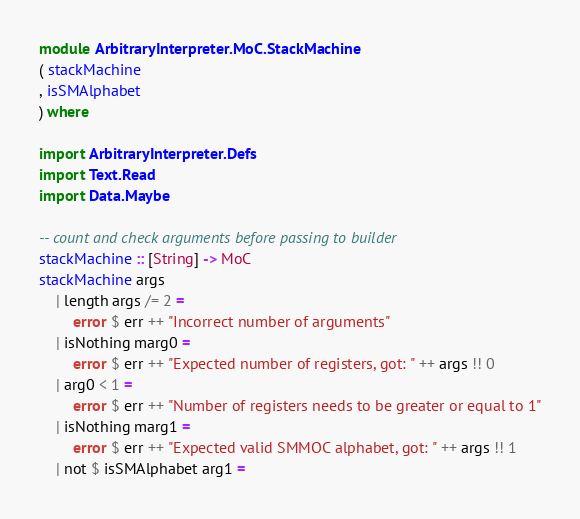<code> <loc_0><loc_0><loc_500><loc_500><_Haskell_>module ArbitraryInterpreter.MoC.StackMachine
( stackMachine
, isSMAlphabet
) where

import ArbitraryInterpreter.Defs
import Text.Read
import Data.Maybe

-- count and check arguments before passing to builder
stackMachine :: [String] -> MoC
stackMachine args
    | length args /= 2 =
        error $ err ++ "Incorrect number of arguments"
    | isNothing marg0 =
        error $ err ++ "Expected number of registers, got: " ++ args !! 0
    | arg0 < 1 =
        error $ err ++ "Number of registers needs to be greater or equal to 1"
    | isNothing marg1 =
        error $ err ++ "Expected valid SMMOC alphabet, got: " ++ args !! 1
    | not $ isSMAlphabet arg1 =</code> 